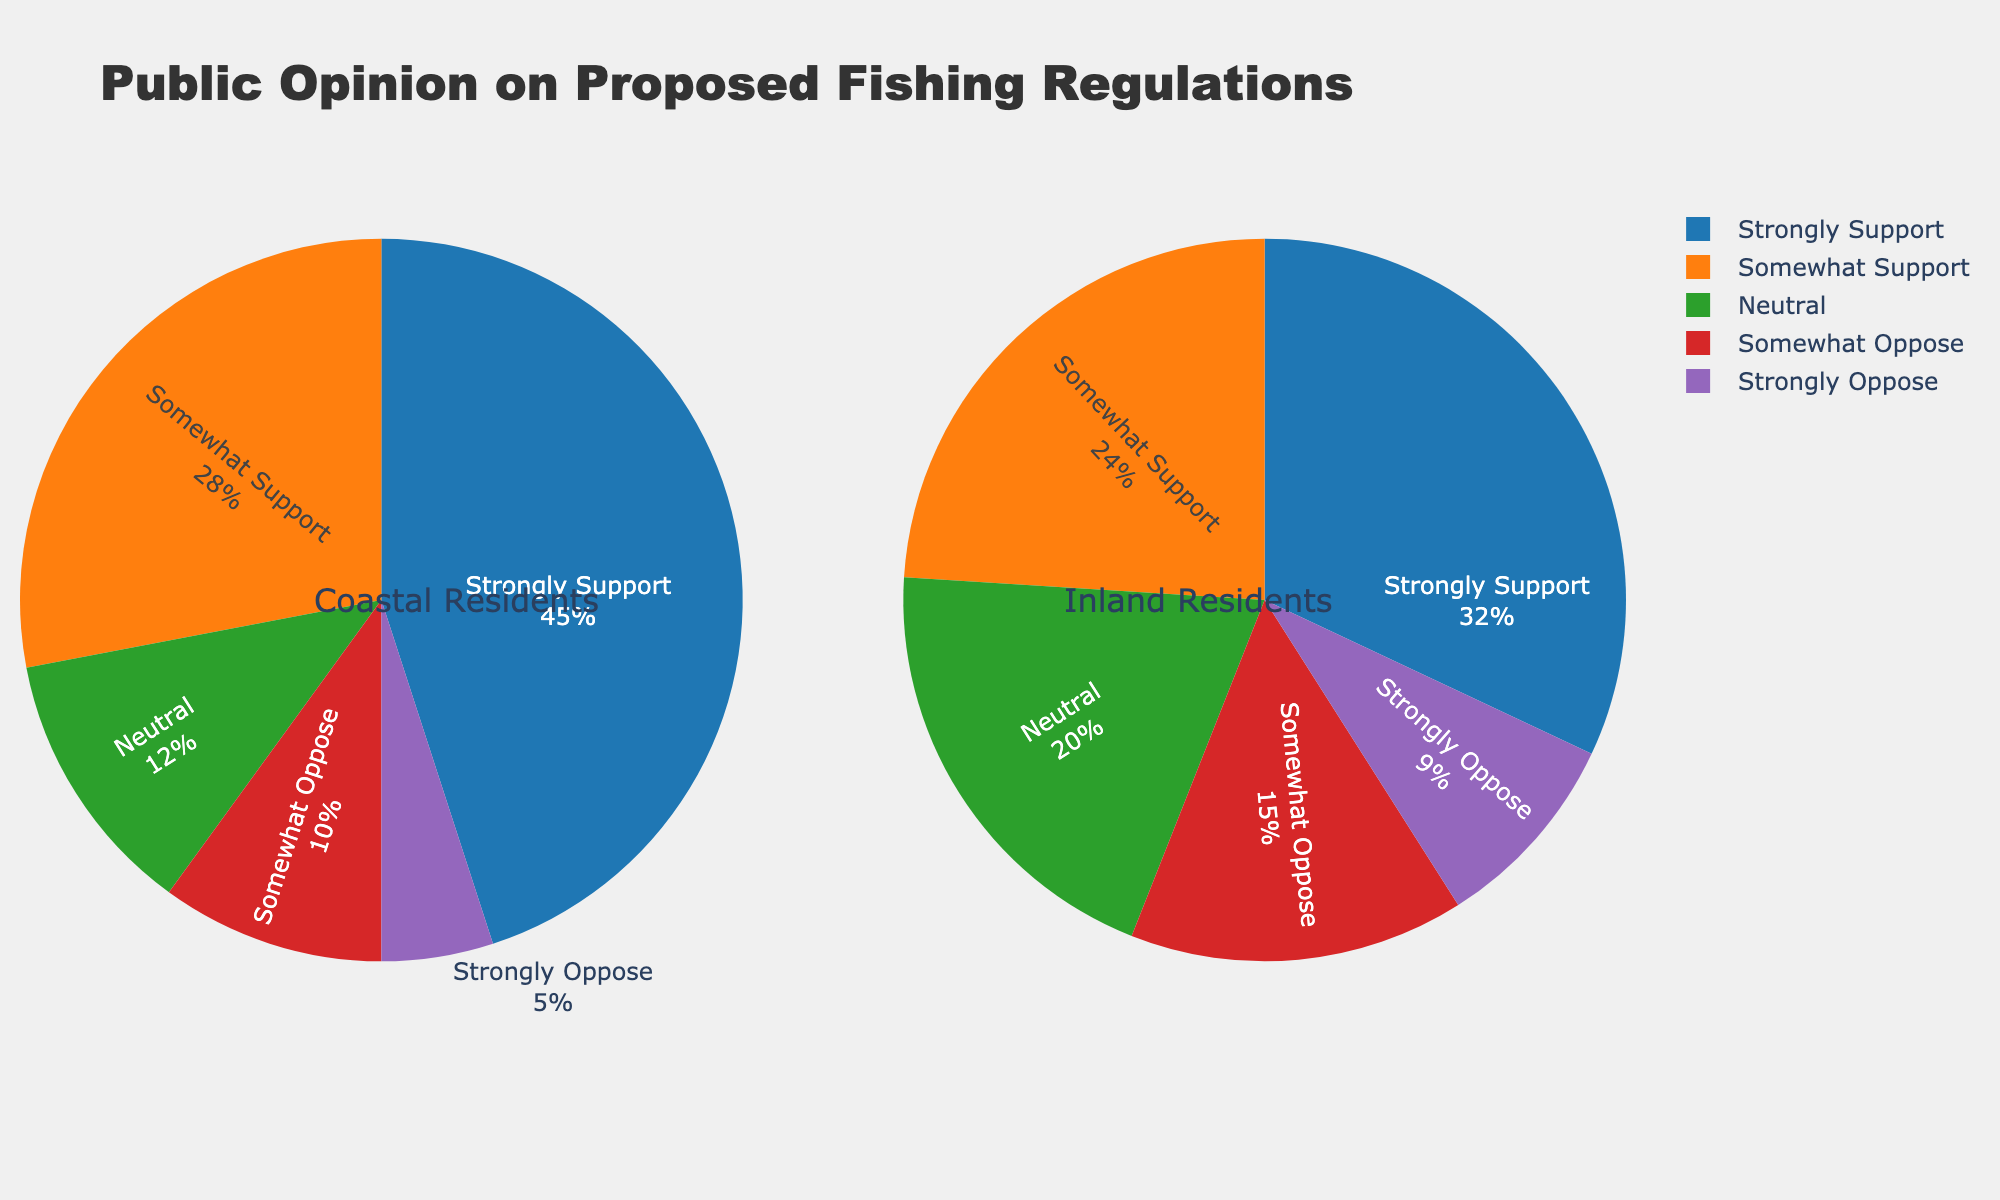Which category has the highest percentage of support among coastal residents? From the pie chart, inspect the segments for coastal residents and identify which one has the largest percentage. The "Strongly Support" segment is the largest.
Answer: Strongly Support What percentage of inland residents are neutral towards the proposed fishing regulations? Refer to the pie chart for inland residents and find the "Neutral" segment to see its percentage. The "Neutral" segment shows 20%.
Answer: 20% How much higher is the "Strongly Support" percentage among coastal residents compared to inland residents? Compare the "Strongly Support" segment percentages from both charts: 45% (coastal) vs. 32% (inland). Calculate the difference: 45% - 32% = 13%.
Answer: 13% Which group has a higher percentage of "Somewhat Oppose" opinions, coastal or inland residents? Compare the "Somewhat Oppose" segment in both pie charts. Coastal residents have 10% and inland residents have 15%. Inland has a higher percentage.
Answer: Inland residents Between coastal and inland residents, who has a higher combined percentage of "Strongly Support" and "Somewhat Support" opinions? Sum the "Strongly Support" and "Somewhat Support" segments for each group: Coastal: 45% + 28% = 73%, Inland: 32% + 24% = 56%. Coastal residents have a higher combined percentage.
Answer: Coastal residents What is the combined percentage of people who oppose (both "Somewhat Oppose" and "Strongly Oppose") the fishing regulations among inland residents? Add the "Somewhat Oppose" and "Strongly Oppose" segments for inland residents: 15% + 9% = 24%.
Answer: 24% Which segment has the smallest percentage among coastal residents? Identify the segment with the smallest percentage in the coastal residents' pie chart. The "Strongly Oppose" segment is the smallest at 5%.
Answer: Strongly Oppose What is the percentage difference in "Neutral" opinions between coastal and inland residents? Compare the "Neutral" percentages: 12% (coastal) vs. 20% (inland). Calculate the difference: 20% - 12% = 8%.
Answer: 8% Based on the visual attributes of the charts, which group shows a higher visual dominance of supportive opinions ("Strongly Support" + "Somewhat Support")? Visually, the coastal residents' chart has a noticeably larger area covered by supportive segments (45% + 28%) compared to inland residents (32% + 24%).
Answer: Coastal residents 